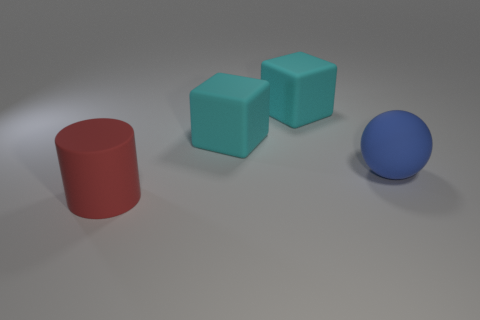How many large matte objects are to the right of the red cylinder and left of the large blue matte ball?
Provide a succinct answer. 2. There is a matte cylinder; how many objects are to the right of it?
Offer a terse response. 3. How many cylinders are either large cyan rubber things or red rubber things?
Give a very brief answer. 1. What number of cyan blocks are made of the same material as the blue thing?
Keep it short and to the point. 2. Is the number of big things that are in front of the blue matte object less than the number of purple cubes?
Keep it short and to the point. No. There is a ball that is the same size as the cylinder; what material is it?
Provide a short and direct response. Rubber. Are there fewer matte cylinders on the left side of the rubber cylinder than cylinders right of the blue matte ball?
Your response must be concise. No. Are there any metal objects?
Offer a very short reply. No. There is a large thing in front of the matte sphere; what is its color?
Make the answer very short. Red. Are there any big cyan objects behind the big red cylinder?
Your response must be concise. Yes. 